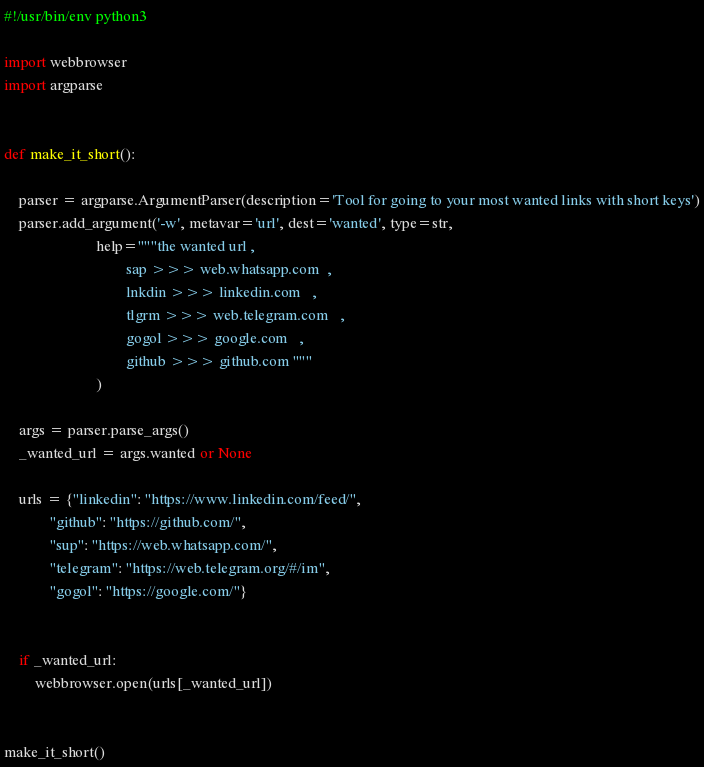Convert code to text. <code><loc_0><loc_0><loc_500><loc_500><_Python_>#!/usr/bin/env python3

import webbrowser
import argparse


def make_it_short():

    parser = argparse.ArgumentParser(description='Tool for going to your most wanted links with short keys')
    parser.add_argument('-w', metavar='url', dest='wanted', type=str,
                        help="""the wanted url , 
                                sap >>> web.whatsapp.com  ,
                                lnkdin >>> linkedin.com   ,
                                tlgrm >>> web.telegram.com   ,
                                gogol >>> google.com   ,
                                github >>> github.com """
                        )

    args = parser.parse_args()
    _wanted_url = args.wanted or None

    urls = {"linkedin": "https://www.linkedin.com/feed/",
            "github": "https://github.com/",
            "sup": "https://web.whatsapp.com/",
            "telegram": "https://web.telegram.org/#/im",
            "gogol": "https://google.com/"}

   
    if _wanted_url:
        webbrowser.open(urls[_wanted_url])


make_it_short()
</code> 